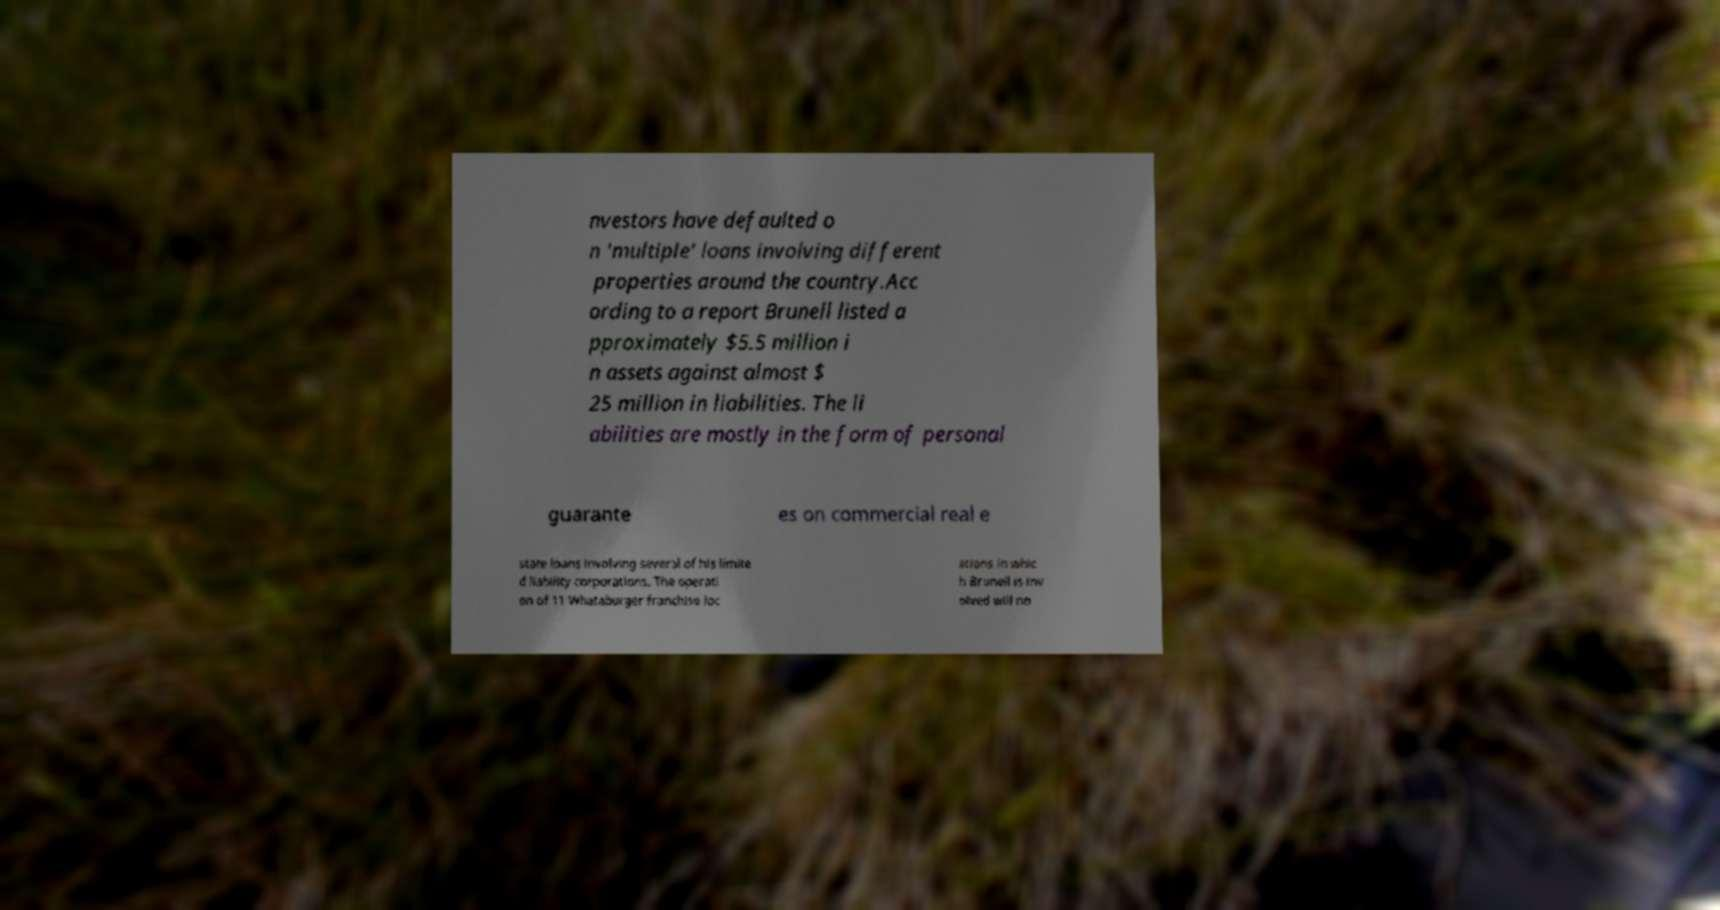Please identify and transcribe the text found in this image. nvestors have defaulted o n 'multiple' loans involving different properties around the country.Acc ording to a report Brunell listed a pproximately $5.5 million i n assets against almost $ 25 million in liabilities. The li abilities are mostly in the form of personal guarante es on commercial real e state loans involving several of his limite d liability corporations. The operati on of 11 Whataburger franchise loc ations in whic h Brunell is inv olved will no 